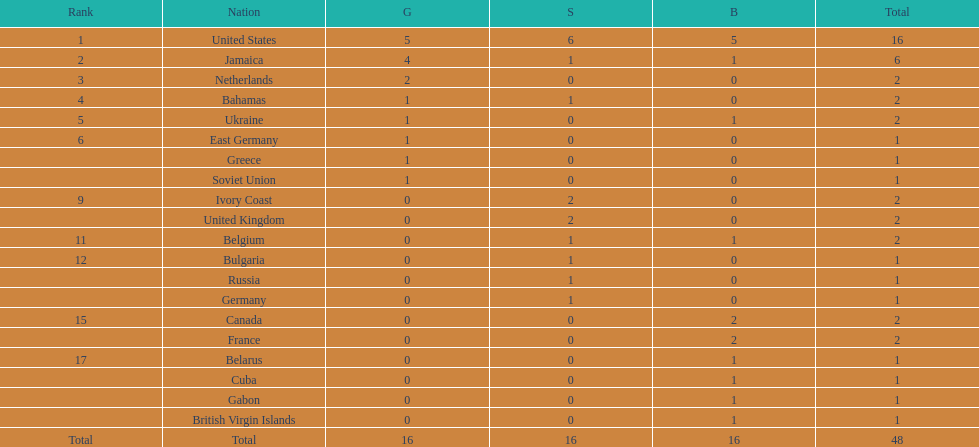Which countries won at least 3 silver medals? United States. 